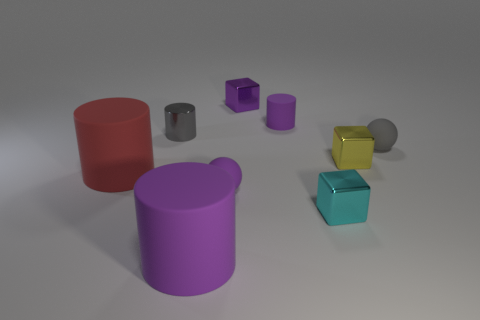The metallic block that is the same color as the tiny matte cylinder is what size?
Offer a terse response. Small. Are there any small balls that have the same color as the metal cylinder?
Offer a very short reply. Yes. There is another ball that is the same size as the gray matte sphere; what color is it?
Your answer should be compact. Purple. Is the color of the metal cylinder the same as the tiny ball on the right side of the small purple cylinder?
Keep it short and to the point. Yes. The tiny metal cylinder is what color?
Your response must be concise. Gray. There is a tiny object left of the large purple thing; what is its material?
Offer a very short reply. Metal. What is the size of the cyan shiny thing that is the same shape as the yellow thing?
Give a very brief answer. Small. Is the number of small yellow metal things that are to the left of the small yellow shiny object less than the number of large brown rubber cylinders?
Offer a very short reply. No. Is there a big blue block?
Give a very brief answer. No. What is the color of the small metal thing that is the same shape as the large red rubber object?
Provide a short and direct response. Gray. 